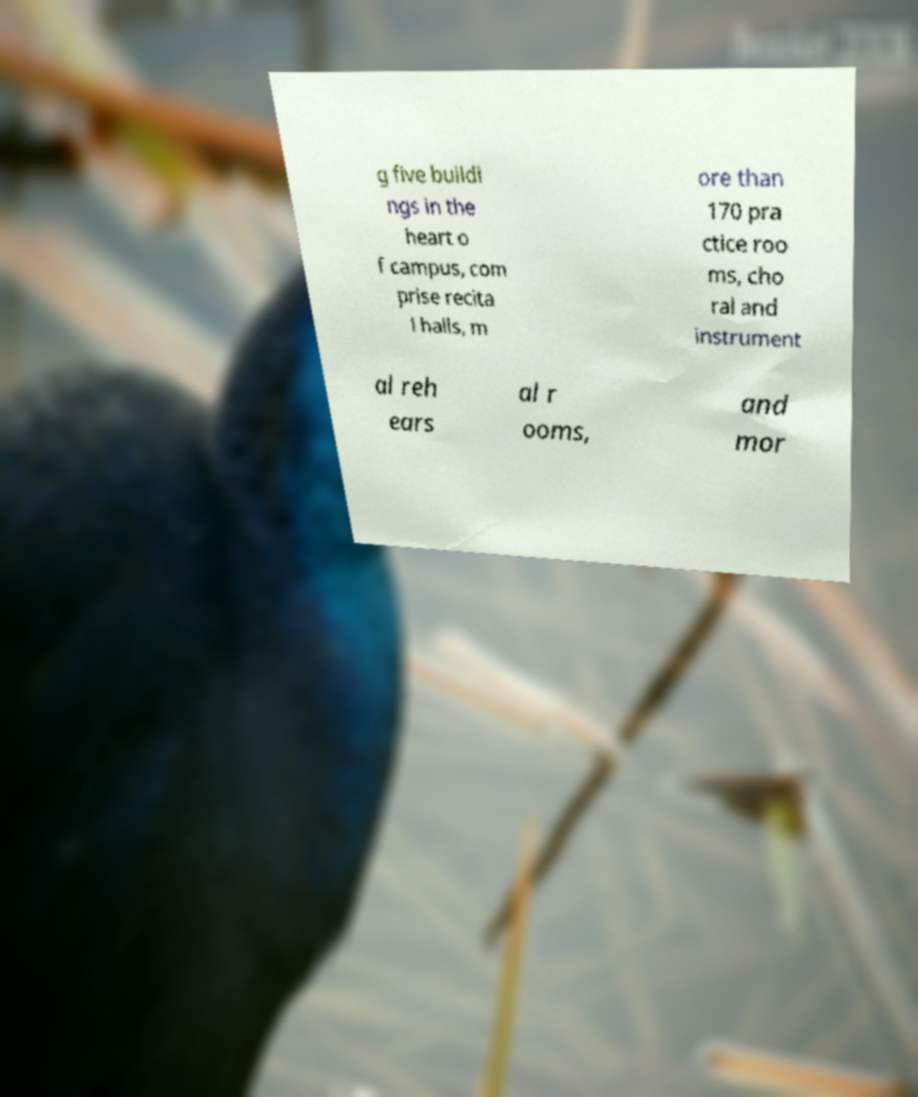Please identify and transcribe the text found in this image. g five buildi ngs in the heart o f campus, com prise recita l halls, m ore than 170 pra ctice roo ms, cho ral and instrument al reh ears al r ooms, and mor 